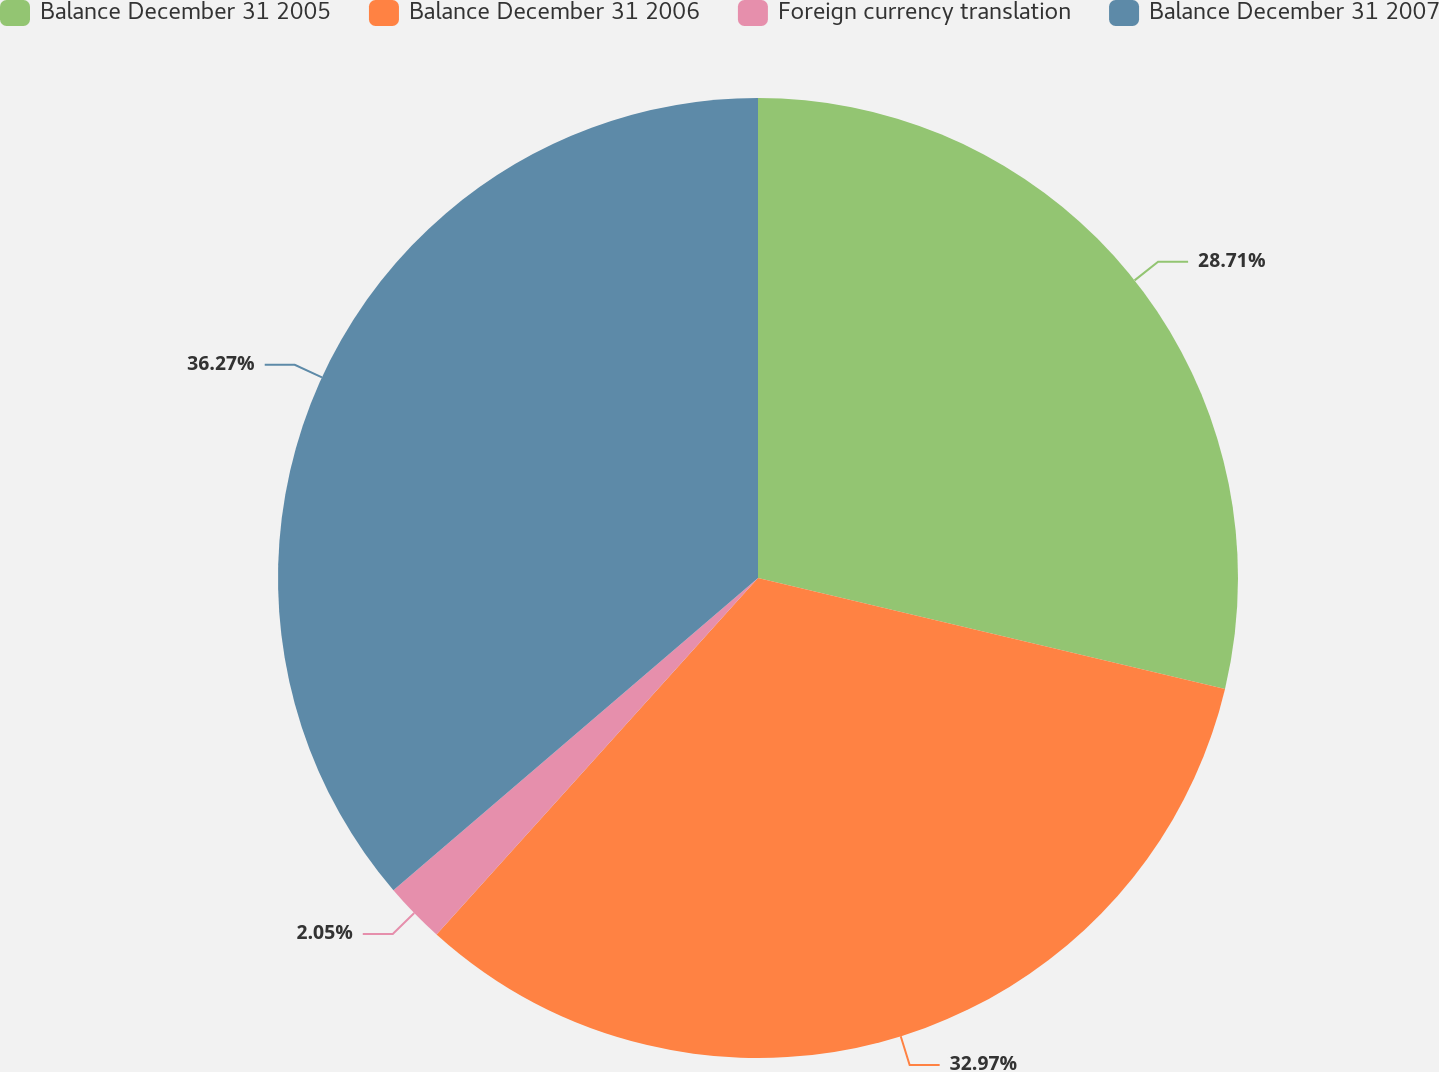Convert chart. <chart><loc_0><loc_0><loc_500><loc_500><pie_chart><fcel>Balance December 31 2005<fcel>Balance December 31 2006<fcel>Foreign currency translation<fcel>Balance December 31 2007<nl><fcel>28.71%<fcel>32.97%<fcel>2.05%<fcel>36.27%<nl></chart> 